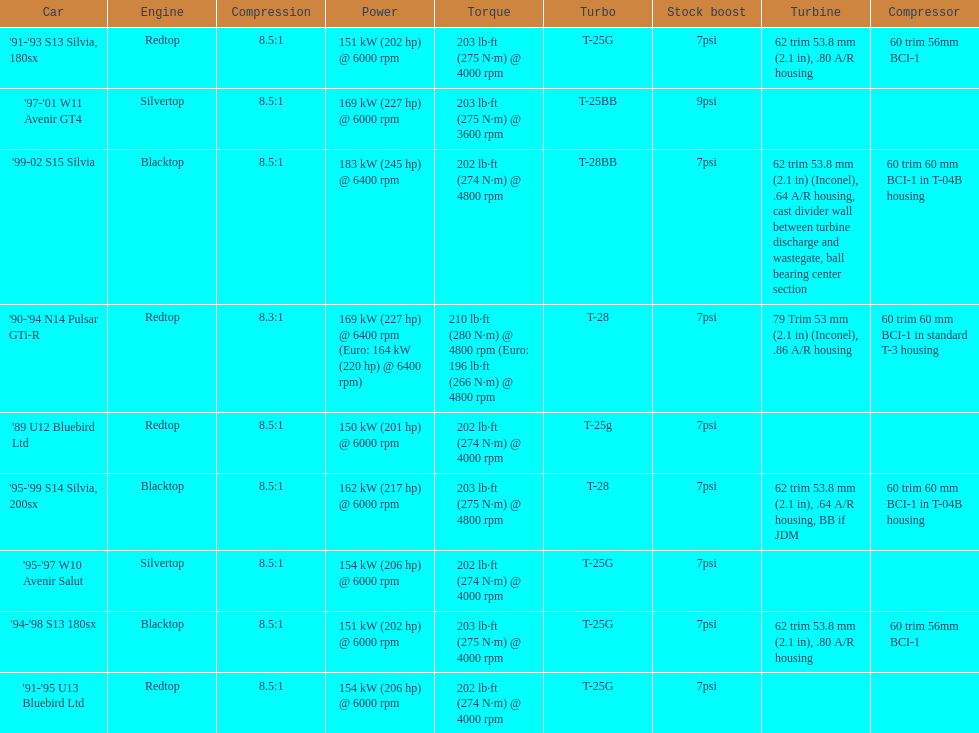Which engine(s) has the least amount of power? Redtop. 